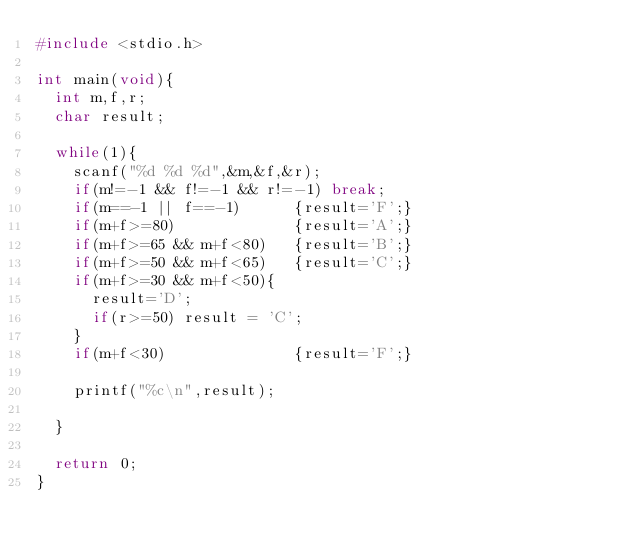Convert code to text. <code><loc_0><loc_0><loc_500><loc_500><_C_>#include <stdio.h>

int main(void){
  int m,f,r;
  char result;

  while(1){
    scanf("%d %d %d",&m,&f,&r);
    if(m!=-1 && f!=-1 && r!=-1) break;
    if(m==-1 || f==-1)      {result='F';}
    if(m+f>=80)             {result='A';}
    if(m+f>=65 && m+f<80)   {result='B';}
    if(m+f>=50 && m+f<65)   {result='C';}
    if(m+f>=30 && m+f<50){
      result='D';
      if(r>=50) result = 'C';
    }
    if(m+f<30)              {result='F';}

    printf("%c\n",result);

  }

  return 0;
}</code> 